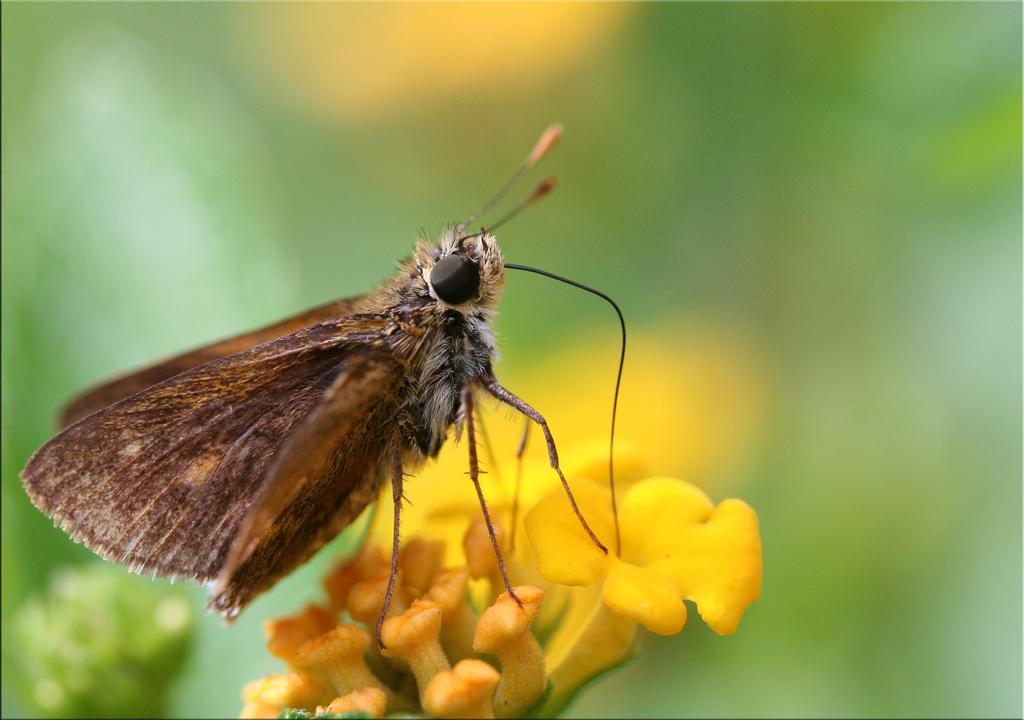What is present in the image? There is a fly and a flower in the image. Where is the fly located in relation to the flower? The fly is on the flower. What is the main focus of the image? The flower is in the center of the image. What type of attack is the fly planning on the baseball in the image? There is no baseball present in the image, so the fly cannot be planning an attack on it. 